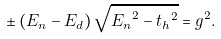Convert formula to latex. <formula><loc_0><loc_0><loc_500><loc_500>\pm \left ( E _ { n } - E _ { d } \right ) \sqrt { { E _ { n } } ^ { 2 } - { t _ { h } } ^ { 2 } } = g ^ { 2 } .</formula> 